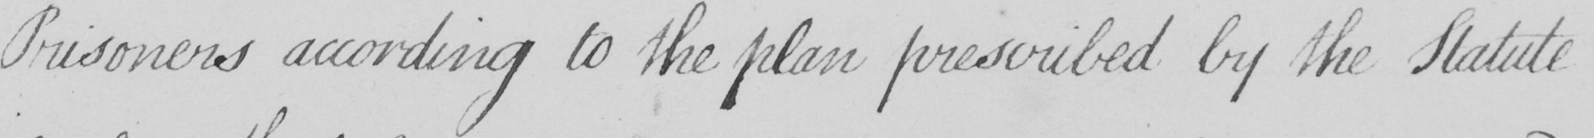Can you read and transcribe this handwriting? Prisoners according to the plan prescribed by the Statute 